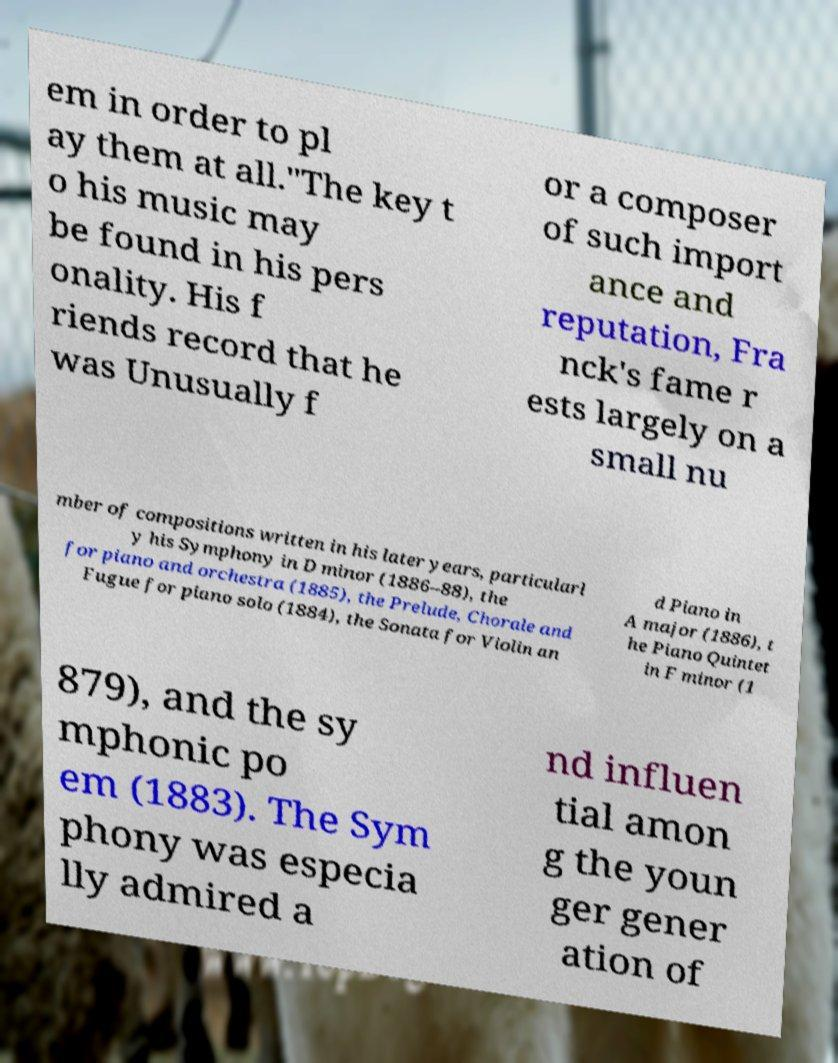For documentation purposes, I need the text within this image transcribed. Could you provide that? em in order to pl ay them at all."The key t o his music may be found in his pers onality. His f riends record that he was Unusually f or a composer of such import ance and reputation, Fra nck's fame r ests largely on a small nu mber of compositions written in his later years, particularl y his Symphony in D minor (1886–88), the for piano and orchestra (1885), the Prelude, Chorale and Fugue for piano solo (1884), the Sonata for Violin an d Piano in A major (1886), t he Piano Quintet in F minor (1 879), and the sy mphonic po em (1883). The Sym phony was especia lly admired a nd influen tial amon g the youn ger gener ation of 